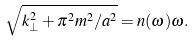Convert formula to latex. <formula><loc_0><loc_0><loc_500><loc_500>\sqrt { k _ { \perp } ^ { 2 } + \pi ^ { 2 } m ^ { 2 } / a ^ { 2 } } = n ( \omega ) \omega .</formula> 